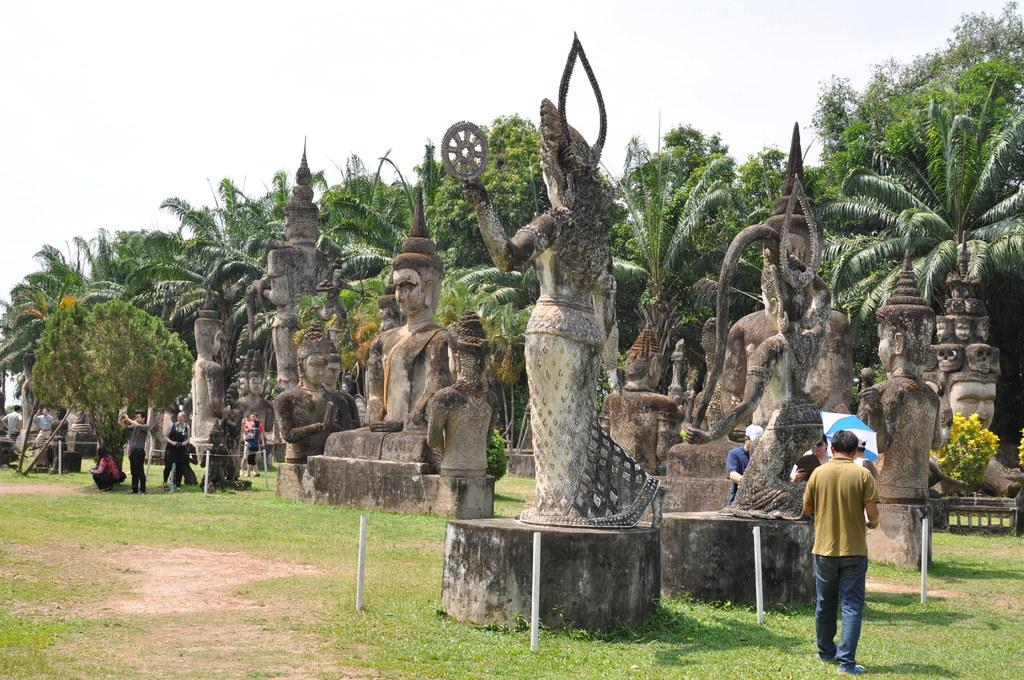What can be seen in the image that represents artistic creations? There are statues in the image. What are the people in the image doing? There are people standing on the ground in the image. What objects are present that might be used for support or construction? There are rods in the image. What is an object in the image that provides shade or protection from the elements? There is an umbrella in the image. What type of natural scenery is visible in the background of the image? There are trees in the background of the image. What is the condition of the sky in the image? The sky is visible in the background of the image. What type of can is being used to cook the stew in the image? There is no can or stew present in the image. What color is the silver statue in the image? There is no silver statue present in the image. 